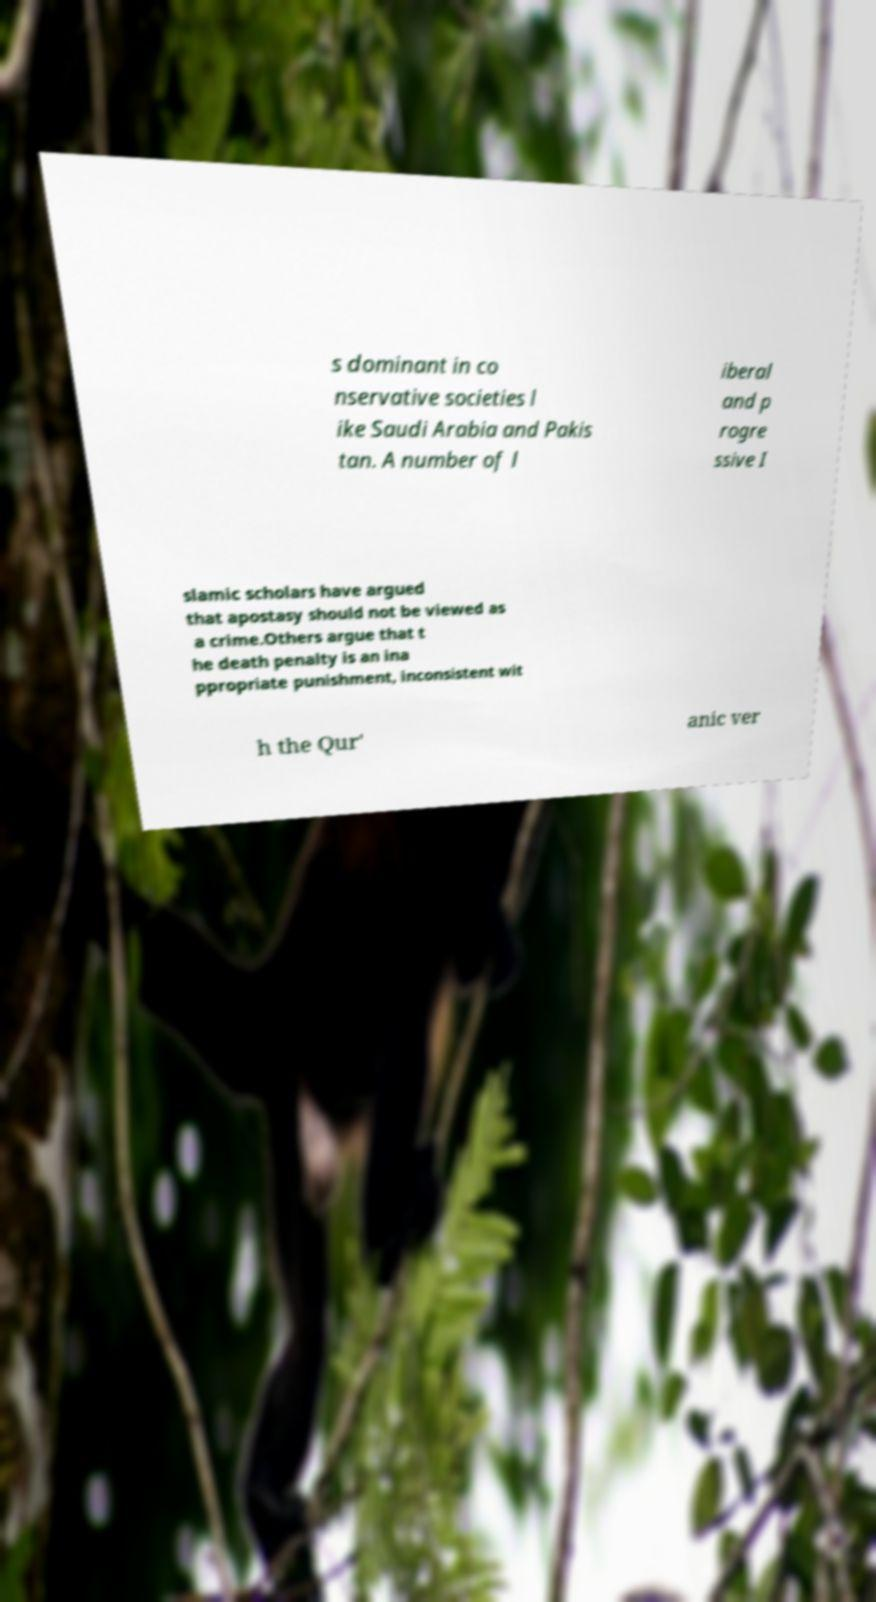There's text embedded in this image that I need extracted. Can you transcribe it verbatim? s dominant in co nservative societies l ike Saudi Arabia and Pakis tan. A number of l iberal and p rogre ssive I slamic scholars have argued that apostasy should not be viewed as a crime.Others argue that t he death penalty is an ina ppropriate punishment, inconsistent wit h the Qur' anic ver 